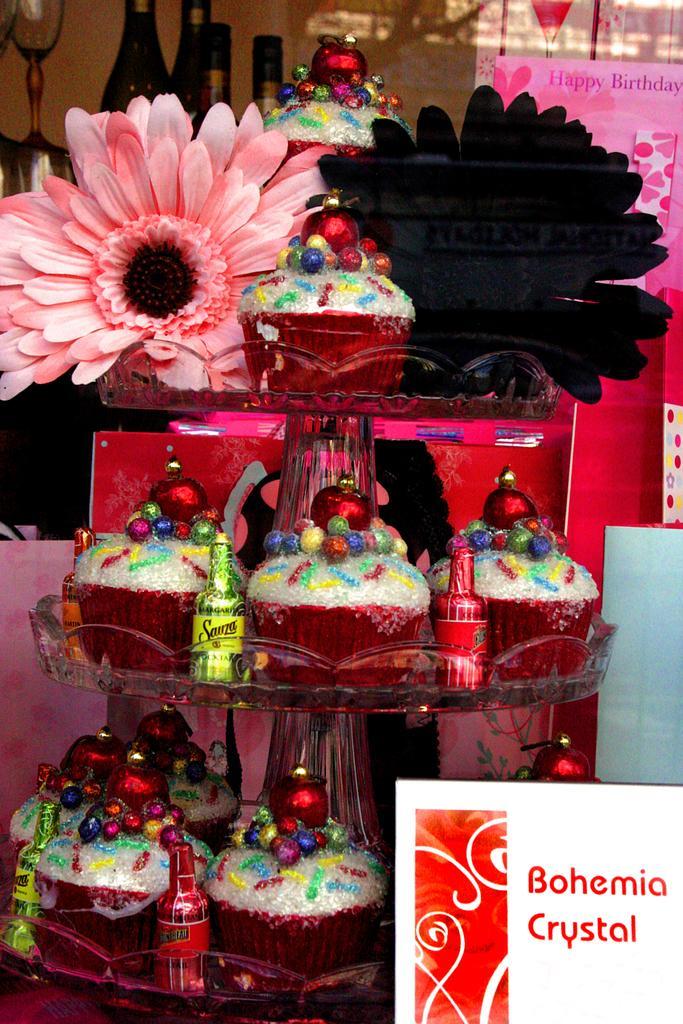Please provide a concise description of this image. In this picture we can see bottles, glasses, flowers, cupcakes, decorative items, cards and some objects. 